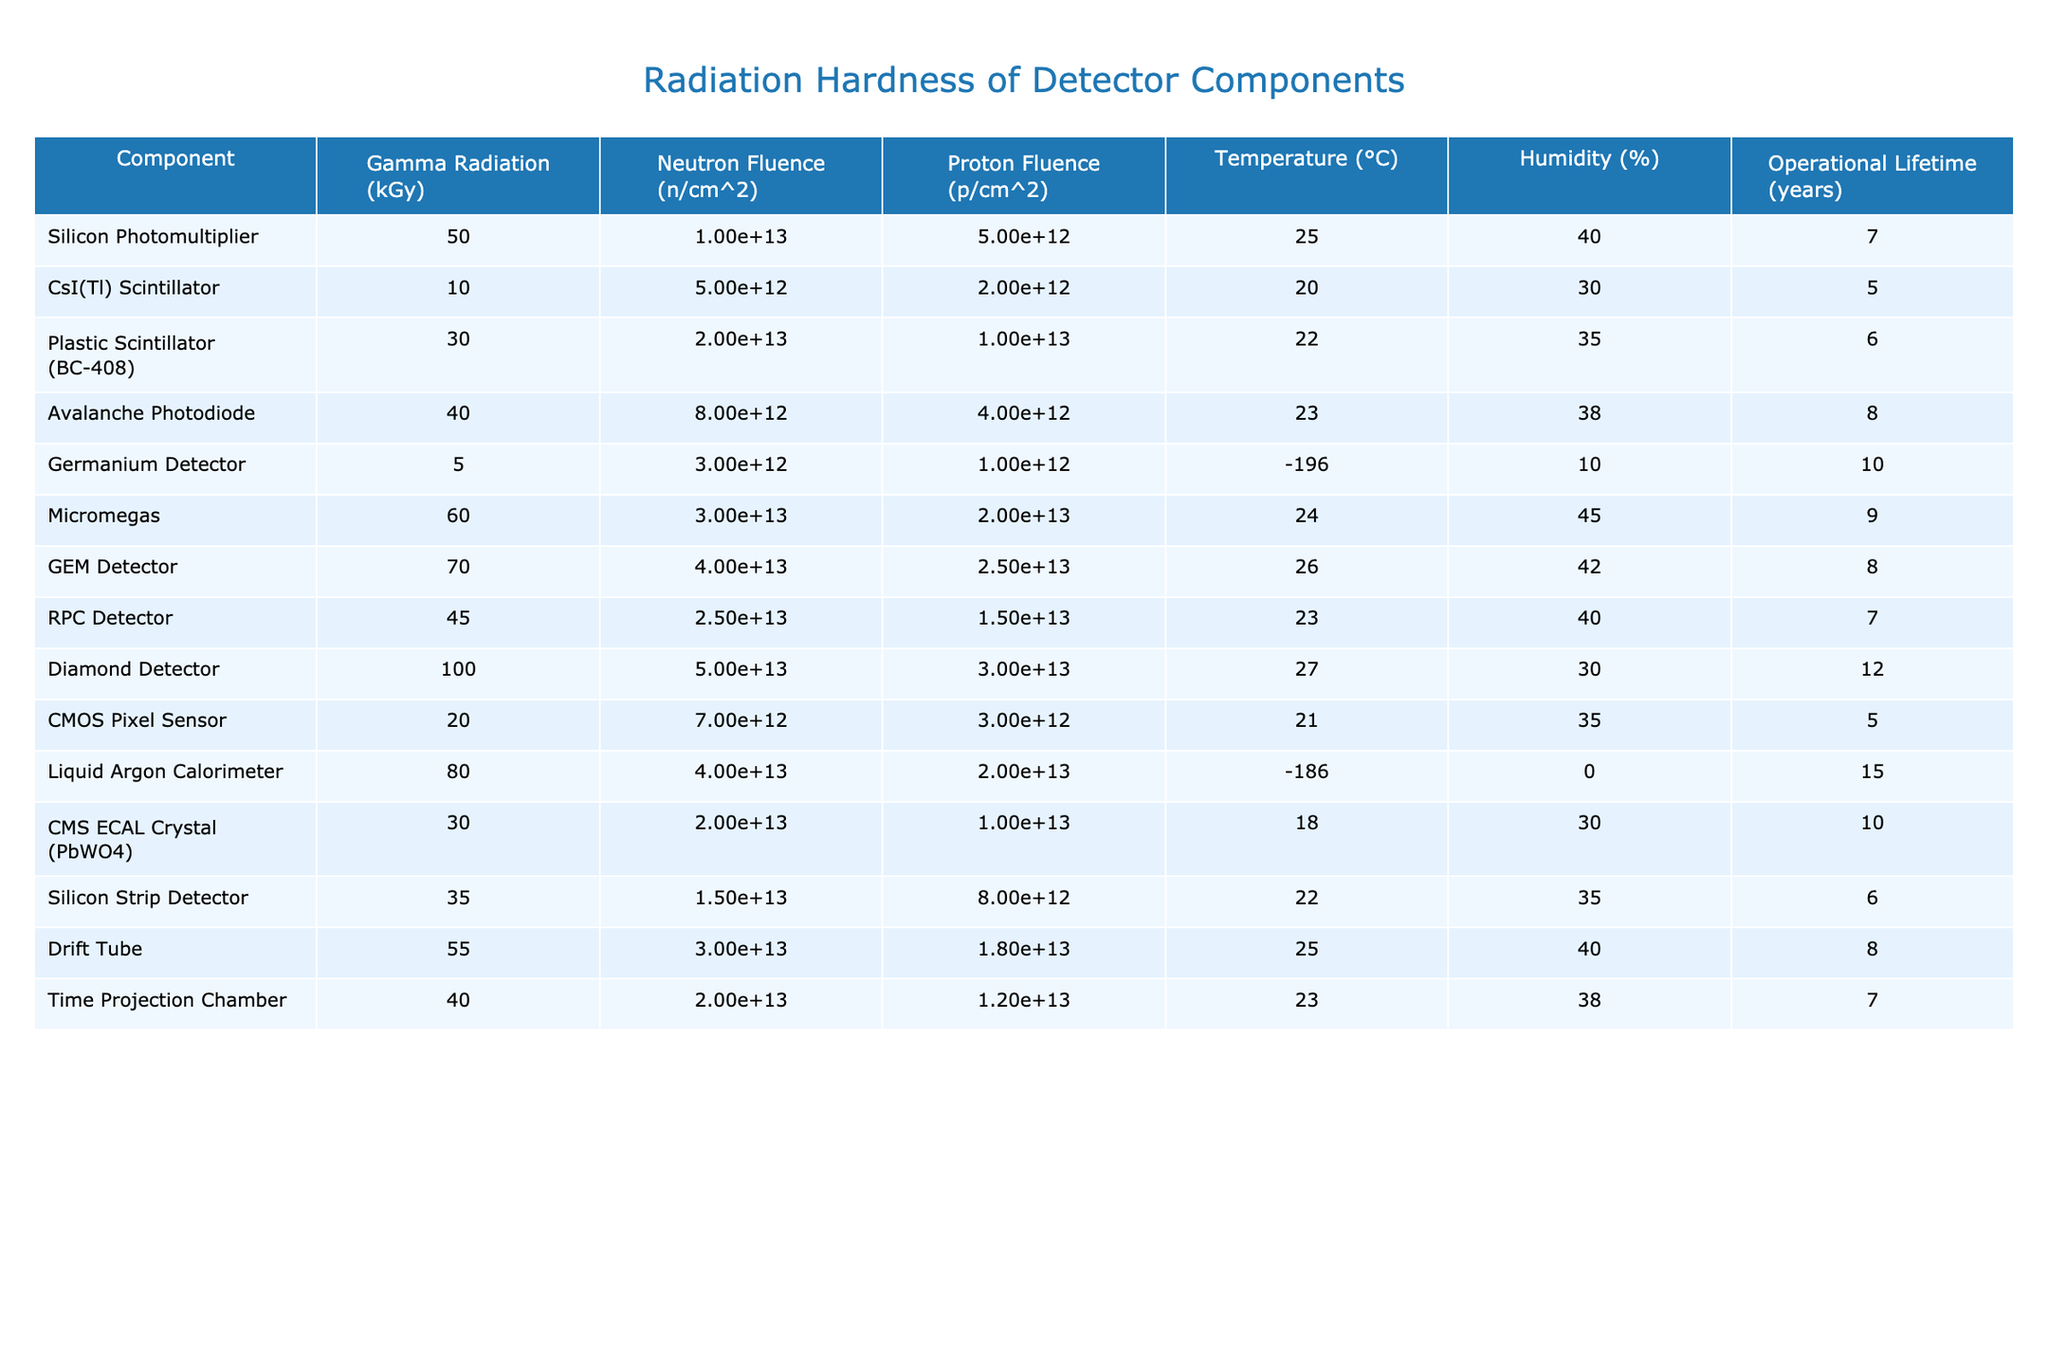What is the operational lifetime of the Diamond Detector? The operational lifetime for the Diamond Detector is given directly in the table under "Operational Lifetime (years)," which states it is 12 years.
Answer: 12 years Which detector component has the highest Gamma Radiation exposure? By inspecting the "Gamma Radiation (kGy)" column, we find that the Diamond Detector has the highest exposure at 100 kGy.
Answer: 100 kGy Does the Liquid Argon Calorimeter operate at a higher temperature than the Germanium Detector? The temperatures listed are -186 °C for the Liquid Argon Calorimeter and -196 °C for the Germanium Detector. Since -186 °C is higher than -196 °C, the answer is yes.
Answer: Yes What is the average time of operational lifetime for all the detectors in the table? The operational lifetimes are: 7, 5, 6, 8, 10, 9, 8, 12, 5, 15, 10, 6, 8, and 7 years. Summing these gives 7 + 5 + 6 + 8 + 10 + 9 + 8 + 12 + 5 + 15 + 10 + 6 + 8 + 7 = 8 years when divided by 14 (number of detectors).
Answer: 8 years Which detector has the highest Neutron Fluence and what is its value? Looking at the "Neutron Fluence (n/cm^2)" column, the Micromegas detector shows the highest value of 3e13 n/cm^2.
Answer: Micromegas, 3e13 n/cm^2 Is there any detector that operates in conditions of 100% humidity? The table shows that all the listed components have humidity values below 100%, meaning none operates at 100% humidity.
Answer: No What is the difference in Gamma Radiation exposure between the Silicon Photomultiplier and the GEM Detector? The Gamma Radiation for the Silicon Photomultiplier is 50 kGy, and for the GEM Detector, it is 70 kGy. The difference is calculated as 70 kGy - 50 kGy = 20 kGy.
Answer: 20 kGy Which detector has the lowest Neutron Fluence, and what is its associated component? Upon reviewing the "Neutron Fluence (n/cm^2)" column, we observe that the Germanium Detector has the lowest value of 3e12 n/cm^2.
Answer: Germanium Detector, 3e12 n/cm^2 What is the relationship between Humidity and Operational Lifetime for the Plastic Scintillator? The Plastic Scintillator has 35% humidity and an operational lifetime of 6 years. This means that its performance may be somewhat influenced by humidity, but no direct relationship is indicated from the provided data.
Answer: Not directly applicable What is the highest temperature recorded for any detector component in the table? Inspecting the "Temperature (°C)" column reveals that Diamond Detector operates at 27 °C, which is the highest temperature recorded among the listed components.
Answer: 27 °C How does the temperature of the CMS ECAL Crystal compare to that of the RPC Detector? The CMS ECAL Crystal operates at 18 °C, while the RPC Detector operates at 23 °C. In this case, 18 °C is lower than 23 °C, indicating a difference in their operating conditions.
Answer: Lower than RPC Detector 